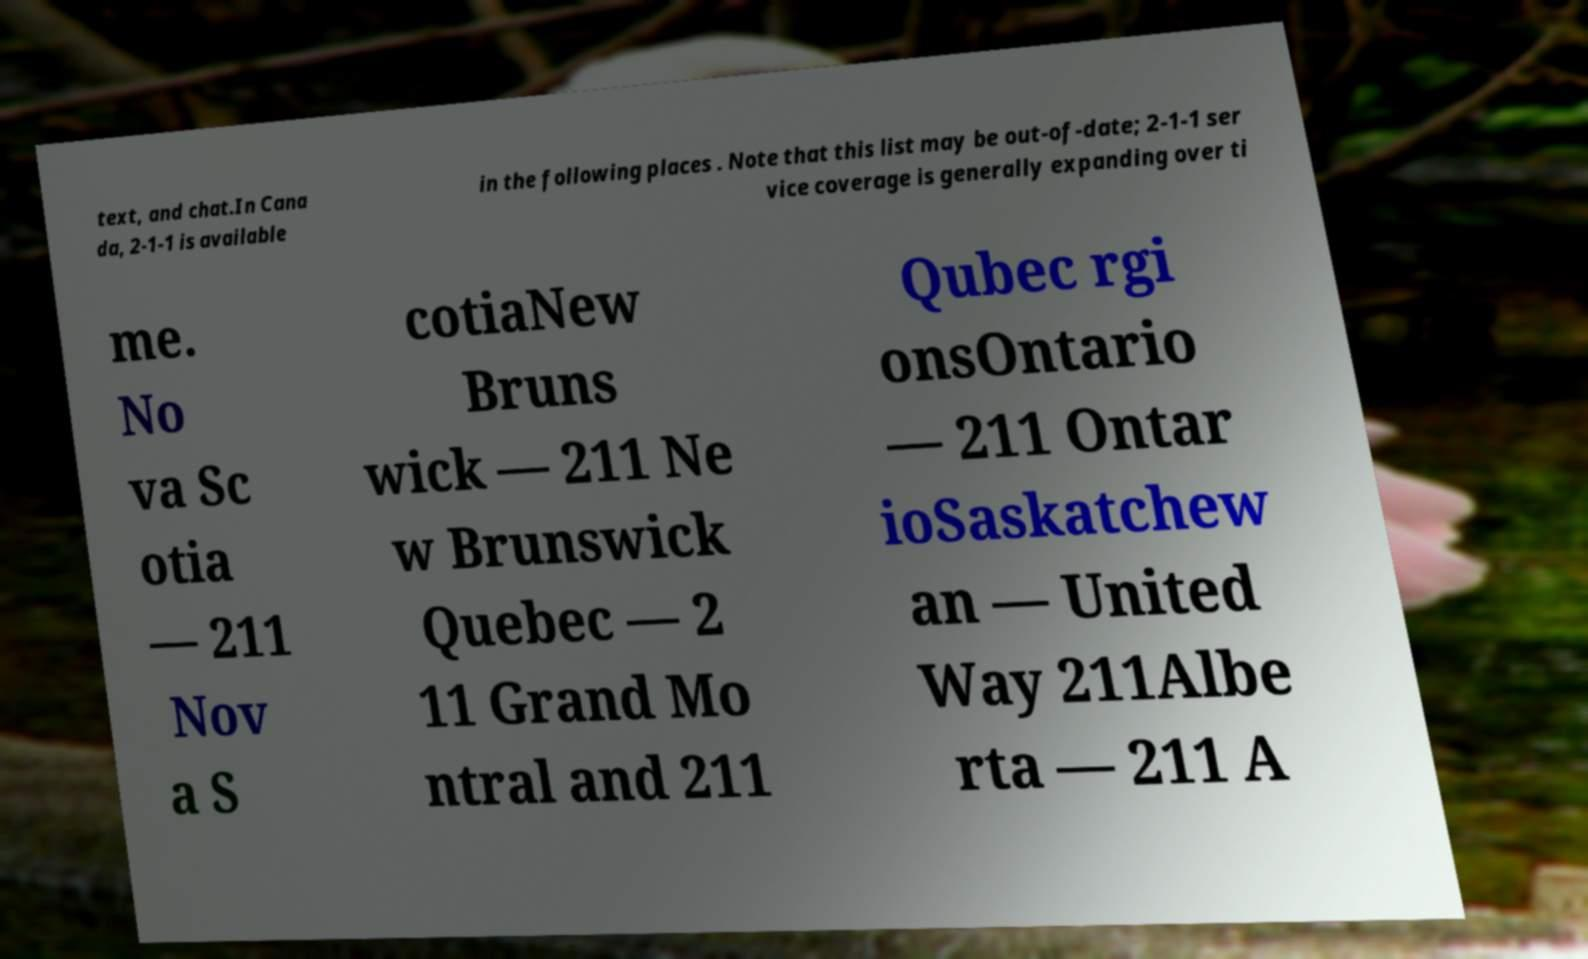Could you assist in decoding the text presented in this image and type it out clearly? text, and chat.In Cana da, 2-1-1 is available in the following places . Note that this list may be out-of-date; 2-1-1 ser vice coverage is generally expanding over ti me. No va Sc otia — 211 Nov a S cotiaNew Bruns wick — 211 Ne w Brunswick Quebec — 2 11 Grand Mo ntral and 211 Qubec rgi onsOntario — 211 Ontar ioSaskatchew an — United Way 211Albe rta — 211 A 